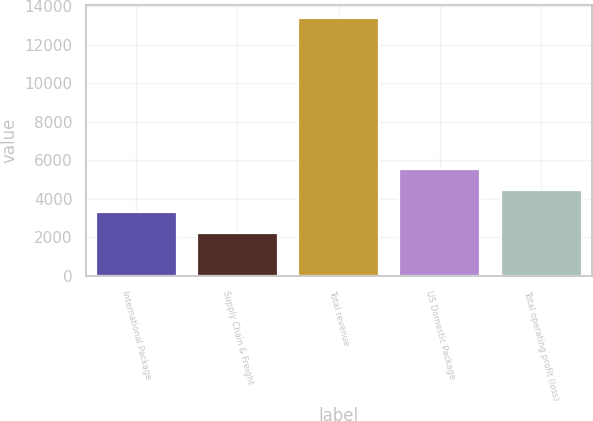Convert chart. <chart><loc_0><loc_0><loc_500><loc_500><bar_chart><fcel>International Package<fcel>Supply Chain & Freight<fcel>Total revenue<fcel>US Domestic Package<fcel>Total operating profit (loss)<nl><fcel>3333.6<fcel>2216<fcel>13392<fcel>5568.8<fcel>4451.2<nl></chart> 